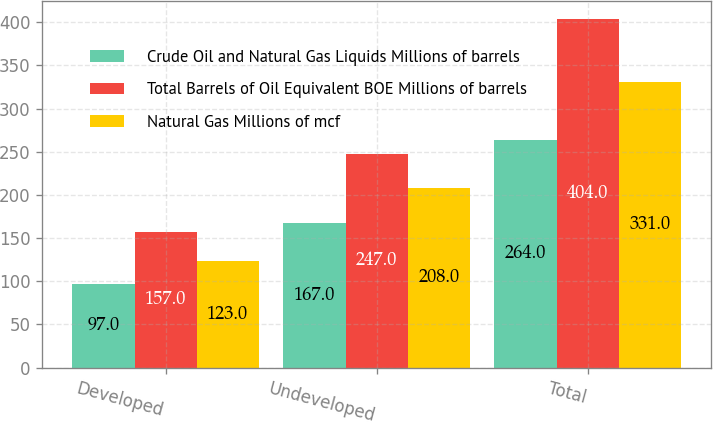<chart> <loc_0><loc_0><loc_500><loc_500><stacked_bar_chart><ecel><fcel>Developed<fcel>Undeveloped<fcel>Total<nl><fcel>Crude Oil and Natural Gas Liquids Millions of barrels<fcel>97<fcel>167<fcel>264<nl><fcel>Total Barrels of Oil Equivalent BOE Millions of barrels<fcel>157<fcel>247<fcel>404<nl><fcel>Natural Gas Millions of mcf<fcel>123<fcel>208<fcel>331<nl></chart> 